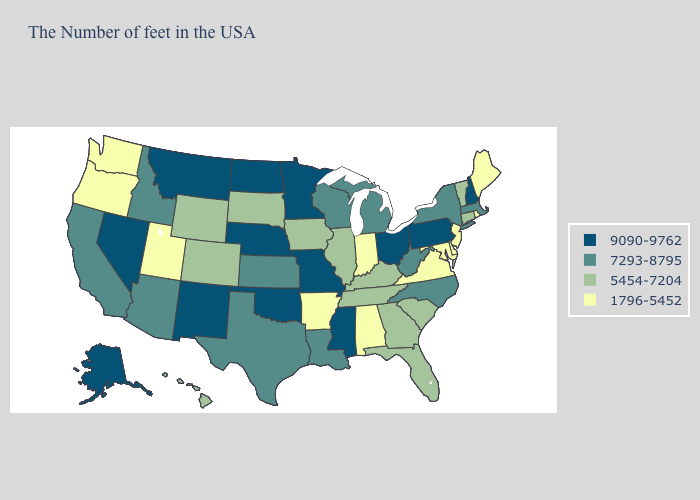What is the value of Iowa?
Quick response, please. 5454-7204. Name the states that have a value in the range 1796-5452?
Be succinct. Maine, Rhode Island, New Jersey, Delaware, Maryland, Virginia, Indiana, Alabama, Arkansas, Utah, Washington, Oregon. Does the first symbol in the legend represent the smallest category?
Answer briefly. No. What is the highest value in states that border Idaho?
Keep it brief. 9090-9762. Which states have the highest value in the USA?
Be succinct. New Hampshire, Pennsylvania, Ohio, Mississippi, Missouri, Minnesota, Nebraska, Oklahoma, North Dakota, New Mexico, Montana, Nevada, Alaska. Does New York have the highest value in the Northeast?
Be succinct. No. Among the states that border Kentucky , does Ohio have the highest value?
Answer briefly. Yes. Name the states that have a value in the range 7293-8795?
Be succinct. Massachusetts, New York, North Carolina, West Virginia, Michigan, Wisconsin, Louisiana, Kansas, Texas, Arizona, Idaho, California. Does Wyoming have a higher value than Maryland?
Give a very brief answer. Yes. Which states hav the highest value in the West?
Concise answer only. New Mexico, Montana, Nevada, Alaska. What is the highest value in the USA?
Quick response, please. 9090-9762. Among the states that border Pennsylvania , which have the lowest value?
Be succinct. New Jersey, Delaware, Maryland. What is the highest value in states that border Connecticut?
Short answer required. 7293-8795. Name the states that have a value in the range 5454-7204?
Short answer required. Vermont, Connecticut, South Carolina, Florida, Georgia, Kentucky, Tennessee, Illinois, Iowa, South Dakota, Wyoming, Colorado, Hawaii. 